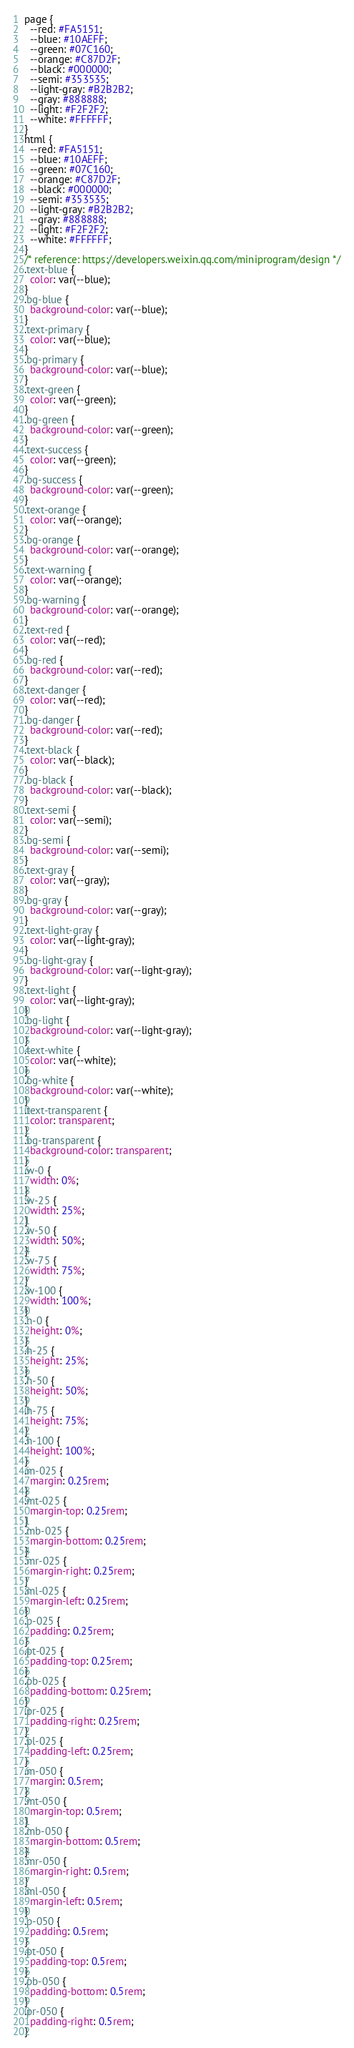<code> <loc_0><loc_0><loc_500><loc_500><_CSS_>page {
  --red: #FA5151;
  --blue: #10AEFF;
  --green: #07C160;
  --orange: #C87D2F;
  --black: #000000;
  --semi: #353535;
  --light-gray: #B2B2B2;
  --gray: #888888;
  --light: #F2F2F2;
  --white: #FFFFFF;
}
html {
  --red: #FA5151;
  --blue: #10AEFF;
  --green: #07C160;
  --orange: #C87D2F;
  --black: #000000;
  --semi: #353535;
  --light-gray: #B2B2B2;
  --gray: #888888;
  --light: #F2F2F2;
  --white: #FFFFFF;
}
/* reference: https://developers.weixin.qq.com/miniprogram/design */
.text-blue {
  color: var(--blue);
}
.bg-blue {
  background-color: var(--blue);
}
.text-primary {
  color: var(--blue);
}
.bg-primary {
  background-color: var(--blue);
}
.text-green {
  color: var(--green);
}
.bg-green {
  background-color: var(--green);
}
.text-success {
  color: var(--green);
}
.bg-success {
  background-color: var(--green);
}
.text-orange {
  color: var(--orange);
}
.bg-orange {
  background-color: var(--orange);
}
.text-warning {
  color: var(--orange);
}
.bg-warning {
  background-color: var(--orange);
}
.text-red {
  color: var(--red);
}
.bg-red {
  background-color: var(--red);
}
.text-danger {
  color: var(--red);
}
.bg-danger {
  background-color: var(--red);
}
.text-black {
  color: var(--black);
}
.bg-black {
  background-color: var(--black);
}
.text-semi {
  color: var(--semi);
}
.bg-semi {
  background-color: var(--semi);
}
.text-gray {
  color: var(--gray);
}
.bg-gray {
  background-color: var(--gray);
}
.text-light-gray {
  color: var(--light-gray);
}
.bg-light-gray {
  background-color: var(--light-gray);
}
.text-light {
  color: var(--light-gray);
}
.bg-light {
  background-color: var(--light-gray);
}
.text-white {
  color: var(--white);
}
.bg-white {
  background-color: var(--white);
}
.text-transparent {
  color: transparent;
}
.bg-transparent {
  background-color: transparent;
}
.w-0 {
  width: 0%;
}
.w-25 {
  width: 25%;
}
.w-50 {
  width: 50%;
}
.w-75 {
  width: 75%;
}
.w-100 {
  width: 100%;
}
.h-0 {
  height: 0%;
}
.h-25 {
  height: 25%;
}
.h-50 {
  height: 50%;
}
.h-75 {
  height: 75%;
}
.h-100 {
  height: 100%;
}
.m-025 {
  margin: 0.25rem;
}
.mt-025 {
  margin-top: 0.25rem;
}
.mb-025 {
  margin-bottom: 0.25rem;
}
.mr-025 {
  margin-right: 0.25rem;
}
.ml-025 {
  margin-left: 0.25rem;
}
.p-025 {
  padding: 0.25rem;
}
.pt-025 {
  padding-top: 0.25rem;
}
.pb-025 {
  padding-bottom: 0.25rem;
}
.pr-025 {
  padding-right: 0.25rem;
}
.pl-025 {
  padding-left: 0.25rem;
}
.m-050 {
  margin: 0.5rem;
}
.mt-050 {
  margin-top: 0.5rem;
}
.mb-050 {
  margin-bottom: 0.5rem;
}
.mr-050 {
  margin-right: 0.5rem;
}
.ml-050 {
  margin-left: 0.5rem;
}
.p-050 {
  padding: 0.5rem;
}
.pt-050 {
  padding-top: 0.5rem;
}
.pb-050 {
  padding-bottom: 0.5rem;
}
.pr-050 {
  padding-right: 0.5rem;
}</code> 